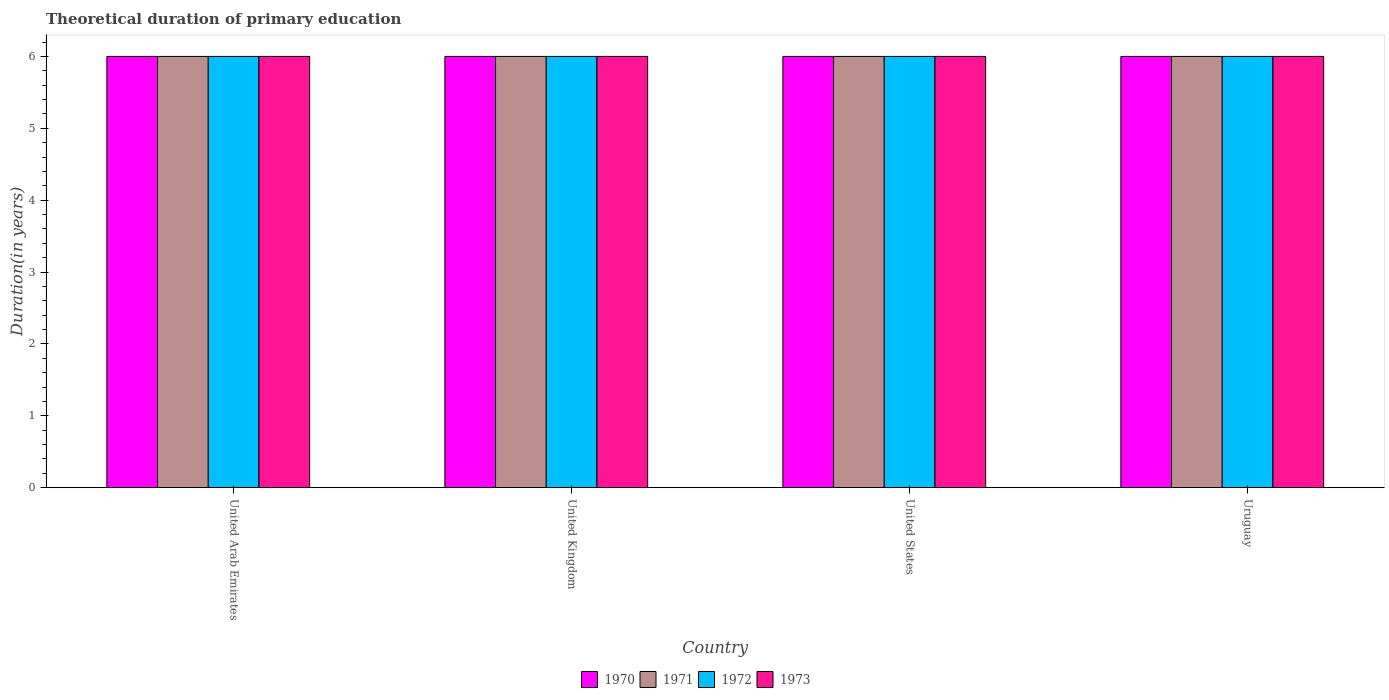How many different coloured bars are there?
Keep it short and to the point. 4. How many bars are there on the 4th tick from the left?
Give a very brief answer. 4. What is the label of the 4th group of bars from the left?
Make the answer very short. Uruguay. Across all countries, what is the maximum total theoretical duration of primary education in 1970?
Your response must be concise. 6. In which country was the total theoretical duration of primary education in 1971 maximum?
Your response must be concise. United Arab Emirates. In which country was the total theoretical duration of primary education in 1973 minimum?
Provide a succinct answer. United Arab Emirates. What is the difference between the total theoretical duration of primary education in 1973 in United States and that in Uruguay?
Offer a terse response. 0. What is the difference between the total theoretical duration of primary education in 1971 in United Kingdom and the total theoretical duration of primary education in 1973 in United States?
Make the answer very short. 0. What is the difference between the total theoretical duration of primary education of/in 1970 and total theoretical duration of primary education of/in 1973 in United States?
Provide a succinct answer. 0. In how many countries, is the total theoretical duration of primary education in 1973 greater than 4.2 years?
Ensure brevity in your answer.  4. Is the total theoretical duration of primary education in 1971 in United Arab Emirates less than that in United States?
Offer a terse response. No. What is the difference between the highest and the lowest total theoretical duration of primary education in 1972?
Provide a succinct answer. 0. In how many countries, is the total theoretical duration of primary education in 1973 greater than the average total theoretical duration of primary education in 1973 taken over all countries?
Your answer should be very brief. 0. Is it the case that in every country, the sum of the total theoretical duration of primary education in 1972 and total theoretical duration of primary education in 1971 is greater than the sum of total theoretical duration of primary education in 1973 and total theoretical duration of primary education in 1970?
Make the answer very short. No. What does the 1st bar from the left in United Kingdom represents?
Your response must be concise. 1970. How many bars are there?
Keep it short and to the point. 16. Are all the bars in the graph horizontal?
Provide a succinct answer. No. Does the graph contain any zero values?
Make the answer very short. No. Where does the legend appear in the graph?
Your response must be concise. Bottom center. How many legend labels are there?
Give a very brief answer. 4. How are the legend labels stacked?
Your answer should be compact. Horizontal. What is the title of the graph?
Provide a succinct answer. Theoretical duration of primary education. What is the label or title of the X-axis?
Your answer should be very brief. Country. What is the label or title of the Y-axis?
Give a very brief answer. Duration(in years). What is the Duration(in years) of 1970 in United Arab Emirates?
Ensure brevity in your answer.  6. What is the Duration(in years) in 1971 in United Arab Emirates?
Your answer should be very brief. 6. What is the Duration(in years) of 1972 in United Arab Emirates?
Provide a succinct answer. 6. What is the Duration(in years) in 1970 in United Kingdom?
Keep it short and to the point. 6. What is the Duration(in years) of 1972 in United Kingdom?
Your answer should be very brief. 6. What is the Duration(in years) of 1973 in United Kingdom?
Your answer should be very brief. 6. What is the Duration(in years) of 1971 in United States?
Provide a short and direct response. 6. What is the Duration(in years) in 1972 in United States?
Provide a succinct answer. 6. What is the Duration(in years) in 1973 in United States?
Provide a short and direct response. 6. What is the Duration(in years) in 1970 in Uruguay?
Keep it short and to the point. 6. What is the Duration(in years) in 1973 in Uruguay?
Offer a terse response. 6. Across all countries, what is the maximum Duration(in years) in 1970?
Offer a terse response. 6. Across all countries, what is the maximum Duration(in years) of 1971?
Your answer should be very brief. 6. Across all countries, what is the maximum Duration(in years) in 1972?
Offer a very short reply. 6. Across all countries, what is the maximum Duration(in years) of 1973?
Keep it short and to the point. 6. Across all countries, what is the minimum Duration(in years) of 1970?
Ensure brevity in your answer.  6. Across all countries, what is the minimum Duration(in years) in 1973?
Give a very brief answer. 6. What is the total Duration(in years) in 1970 in the graph?
Offer a terse response. 24. What is the total Duration(in years) in 1972 in the graph?
Give a very brief answer. 24. What is the total Duration(in years) in 1973 in the graph?
Keep it short and to the point. 24. What is the difference between the Duration(in years) of 1970 in United Arab Emirates and that in United Kingdom?
Make the answer very short. 0. What is the difference between the Duration(in years) of 1973 in United Arab Emirates and that in United Kingdom?
Keep it short and to the point. 0. What is the difference between the Duration(in years) in 1970 in United Arab Emirates and that in United States?
Offer a very short reply. 0. What is the difference between the Duration(in years) of 1971 in United Arab Emirates and that in United States?
Keep it short and to the point. 0. What is the difference between the Duration(in years) in 1973 in United Arab Emirates and that in United States?
Provide a short and direct response. 0. What is the difference between the Duration(in years) of 1971 in United Arab Emirates and that in Uruguay?
Ensure brevity in your answer.  0. What is the difference between the Duration(in years) of 1972 in United Arab Emirates and that in Uruguay?
Offer a terse response. 0. What is the difference between the Duration(in years) of 1973 in United Arab Emirates and that in Uruguay?
Give a very brief answer. 0. What is the difference between the Duration(in years) in 1970 in United Kingdom and that in United States?
Your answer should be very brief. 0. What is the difference between the Duration(in years) of 1972 in United Kingdom and that in United States?
Offer a very short reply. 0. What is the difference between the Duration(in years) of 1970 in United Kingdom and that in Uruguay?
Your response must be concise. 0. What is the difference between the Duration(in years) in 1973 in United Kingdom and that in Uruguay?
Your answer should be very brief. 0. What is the difference between the Duration(in years) in 1970 in United States and that in Uruguay?
Offer a very short reply. 0. What is the difference between the Duration(in years) of 1972 in United States and that in Uruguay?
Ensure brevity in your answer.  0. What is the difference between the Duration(in years) of 1973 in United States and that in Uruguay?
Your answer should be very brief. 0. What is the difference between the Duration(in years) of 1970 in United Arab Emirates and the Duration(in years) of 1971 in United Kingdom?
Provide a succinct answer. 0. What is the difference between the Duration(in years) of 1970 in United Arab Emirates and the Duration(in years) of 1972 in United Kingdom?
Offer a very short reply. 0. What is the difference between the Duration(in years) in 1970 in United Arab Emirates and the Duration(in years) in 1973 in United Kingdom?
Give a very brief answer. 0. What is the difference between the Duration(in years) of 1972 in United Arab Emirates and the Duration(in years) of 1973 in United Kingdom?
Offer a very short reply. 0. What is the difference between the Duration(in years) in 1970 in United Arab Emirates and the Duration(in years) in 1971 in United States?
Your answer should be compact. 0. What is the difference between the Duration(in years) of 1970 in United Arab Emirates and the Duration(in years) of 1973 in United States?
Provide a short and direct response. 0. What is the difference between the Duration(in years) of 1971 in United Arab Emirates and the Duration(in years) of 1972 in United States?
Provide a short and direct response. 0. What is the difference between the Duration(in years) of 1971 in United Arab Emirates and the Duration(in years) of 1973 in United States?
Give a very brief answer. 0. What is the difference between the Duration(in years) in 1970 in United Arab Emirates and the Duration(in years) in 1971 in Uruguay?
Make the answer very short. 0. What is the difference between the Duration(in years) in 1970 in United Arab Emirates and the Duration(in years) in 1972 in Uruguay?
Your answer should be compact. 0. What is the difference between the Duration(in years) in 1970 in United Kingdom and the Duration(in years) in 1971 in United States?
Your response must be concise. 0. What is the difference between the Duration(in years) in 1970 in United Kingdom and the Duration(in years) in 1972 in United States?
Give a very brief answer. 0. What is the difference between the Duration(in years) in 1971 in United Kingdom and the Duration(in years) in 1972 in United States?
Offer a terse response. 0. What is the difference between the Duration(in years) of 1971 in United Kingdom and the Duration(in years) of 1973 in United States?
Offer a very short reply. 0. What is the difference between the Duration(in years) in 1972 in United Kingdom and the Duration(in years) in 1973 in United States?
Give a very brief answer. 0. What is the difference between the Duration(in years) of 1970 in United Kingdom and the Duration(in years) of 1971 in Uruguay?
Offer a very short reply. 0. What is the difference between the Duration(in years) in 1970 in United Kingdom and the Duration(in years) in 1972 in Uruguay?
Give a very brief answer. 0. What is the difference between the Duration(in years) in 1971 in United Kingdom and the Duration(in years) in 1972 in Uruguay?
Your answer should be compact. 0. What is the difference between the Duration(in years) in 1971 in United Kingdom and the Duration(in years) in 1973 in Uruguay?
Give a very brief answer. 0. What is the difference between the Duration(in years) of 1972 in United Kingdom and the Duration(in years) of 1973 in Uruguay?
Offer a terse response. 0. What is the difference between the Duration(in years) of 1970 in United States and the Duration(in years) of 1971 in Uruguay?
Give a very brief answer. 0. What is the difference between the Duration(in years) in 1970 in United States and the Duration(in years) in 1973 in Uruguay?
Provide a succinct answer. 0. What is the difference between the Duration(in years) in 1971 in United States and the Duration(in years) in 1972 in Uruguay?
Your answer should be compact. 0. What is the average Duration(in years) of 1970 per country?
Your response must be concise. 6. What is the average Duration(in years) of 1972 per country?
Offer a terse response. 6. What is the difference between the Duration(in years) in 1970 and Duration(in years) in 1971 in United Arab Emirates?
Your answer should be very brief. 0. What is the difference between the Duration(in years) in 1970 and Duration(in years) in 1972 in United Arab Emirates?
Your answer should be very brief. 0. What is the difference between the Duration(in years) in 1971 and Duration(in years) in 1972 in United Arab Emirates?
Make the answer very short. 0. What is the difference between the Duration(in years) of 1972 and Duration(in years) of 1973 in United Arab Emirates?
Your response must be concise. 0. What is the difference between the Duration(in years) in 1971 and Duration(in years) in 1972 in United Kingdom?
Give a very brief answer. 0. What is the difference between the Duration(in years) of 1970 and Duration(in years) of 1972 in United States?
Offer a terse response. 0. What is the difference between the Duration(in years) of 1971 and Duration(in years) of 1972 in United States?
Provide a short and direct response. 0. What is the difference between the Duration(in years) of 1972 and Duration(in years) of 1973 in United States?
Provide a succinct answer. 0. What is the difference between the Duration(in years) in 1970 and Duration(in years) in 1972 in Uruguay?
Your answer should be very brief. 0. What is the difference between the Duration(in years) of 1970 and Duration(in years) of 1973 in Uruguay?
Offer a terse response. 0. What is the difference between the Duration(in years) in 1971 and Duration(in years) in 1972 in Uruguay?
Provide a succinct answer. 0. What is the ratio of the Duration(in years) in 1973 in United Arab Emirates to that in United Kingdom?
Your response must be concise. 1. What is the ratio of the Duration(in years) in 1972 in United Arab Emirates to that in United States?
Give a very brief answer. 1. What is the ratio of the Duration(in years) of 1971 in United Arab Emirates to that in Uruguay?
Your answer should be very brief. 1. What is the ratio of the Duration(in years) in 1971 in United Kingdom to that in United States?
Your response must be concise. 1. What is the ratio of the Duration(in years) in 1972 in United Kingdom to that in United States?
Provide a short and direct response. 1. What is the ratio of the Duration(in years) in 1973 in United Kingdom to that in United States?
Provide a succinct answer. 1. What is the ratio of the Duration(in years) in 1971 in United Kingdom to that in Uruguay?
Make the answer very short. 1. What is the ratio of the Duration(in years) in 1972 in United Kingdom to that in Uruguay?
Your response must be concise. 1. What is the ratio of the Duration(in years) of 1973 in United Kingdom to that in Uruguay?
Make the answer very short. 1. What is the ratio of the Duration(in years) in 1972 in United States to that in Uruguay?
Your answer should be very brief. 1. What is the difference between the highest and the second highest Duration(in years) in 1970?
Offer a very short reply. 0. What is the difference between the highest and the second highest Duration(in years) in 1971?
Provide a short and direct response. 0. What is the difference between the highest and the second highest Duration(in years) of 1972?
Keep it short and to the point. 0. What is the difference between the highest and the second highest Duration(in years) of 1973?
Your response must be concise. 0. What is the difference between the highest and the lowest Duration(in years) in 1970?
Give a very brief answer. 0. What is the difference between the highest and the lowest Duration(in years) of 1971?
Provide a succinct answer. 0. What is the difference between the highest and the lowest Duration(in years) of 1973?
Offer a very short reply. 0. 